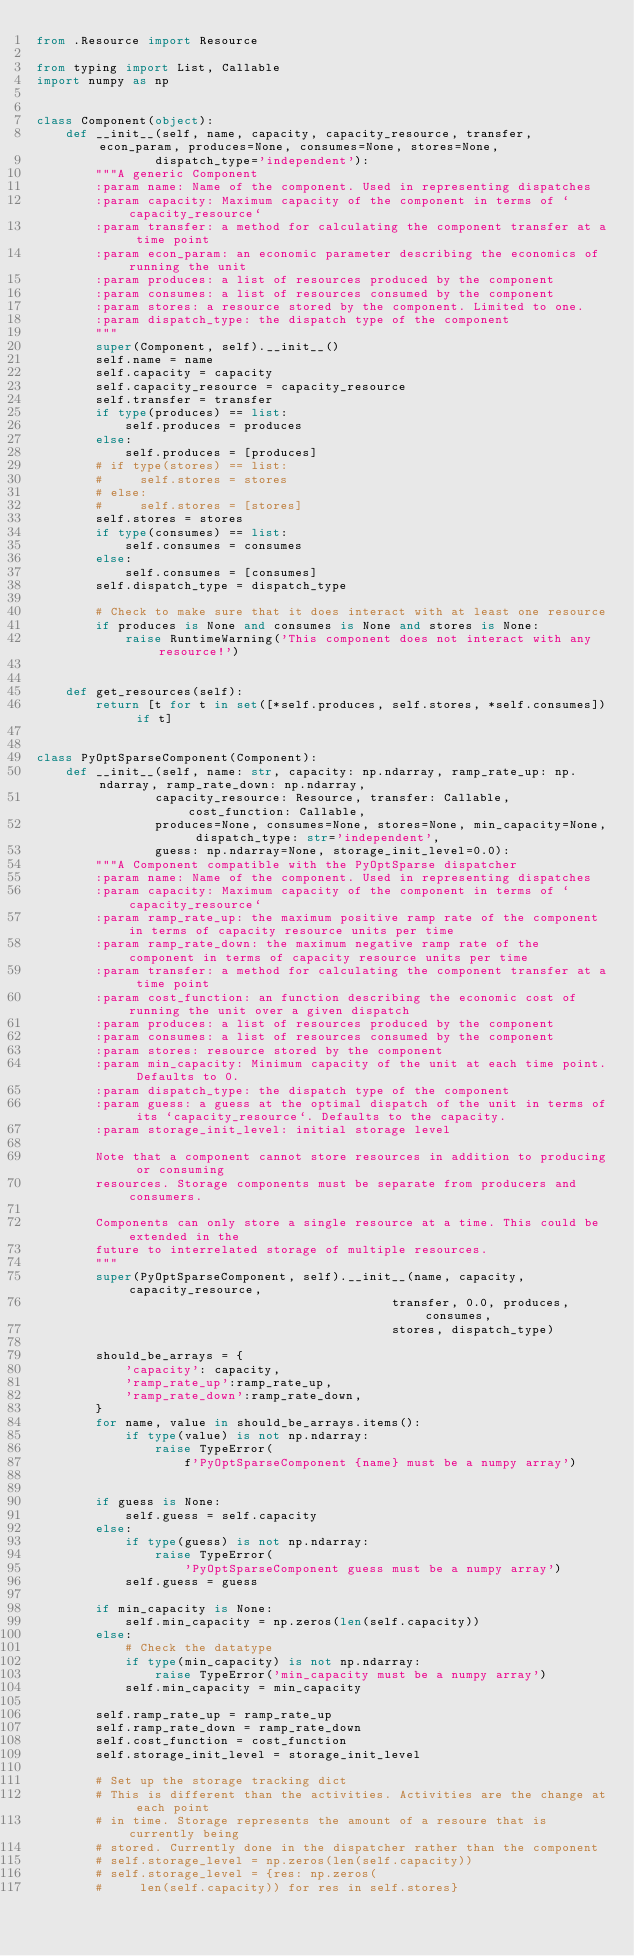Convert code to text. <code><loc_0><loc_0><loc_500><loc_500><_Python_>from .Resource import Resource

from typing import List, Callable
import numpy as np


class Component(object):
    def __init__(self, name, capacity, capacity_resource, transfer, econ_param, produces=None, consumes=None, stores=None,
                dispatch_type='independent'):
        """A generic Component
        :param name: Name of the component. Used in representing dispatches
        :param capacity: Maximum capacity of the component in terms of `capacity_resource`
        :param transfer: a method for calculating the component transfer at a time point
        :param econ_param: an economic parameter describing the economics of running the unit
        :param produces: a list of resources produced by the component
        :param consumes: a list of resources consumed by the component
        :param stores: a resource stored by the component. Limited to one.
        :param dispatch_type: the dispatch type of the component
        """
        super(Component, self).__init__()
        self.name = name
        self.capacity = capacity
        self.capacity_resource = capacity_resource
        self.transfer = transfer
        if type(produces) == list:
            self.produces = produces
        else:
            self.produces = [produces]
        # if type(stores) == list:
        #     self.stores = stores
        # else:
        #     self.stores = [stores]
        self.stores = stores
        if type(consumes) == list:
            self.consumes = consumes
        else:
            self.consumes = [consumes]
        self.dispatch_type = dispatch_type

        # Check to make sure that it does interact with at least one resource
        if produces is None and consumes is None and stores is None:
            raise RuntimeWarning('This component does not interact with any resource!')


    def get_resources(self):
        return [t for t in set([*self.produces, self.stores, *self.consumes]) if t]


class PyOptSparseComponent(Component):
    def __init__(self, name: str, capacity: np.ndarray, ramp_rate_up: np.ndarray, ramp_rate_down: np.ndarray,
                capacity_resource: Resource, transfer: Callable, cost_function: Callable,
                produces=None, consumes=None, stores=None, min_capacity=None, dispatch_type: str='independent',
                guess: np.ndarray=None, storage_init_level=0.0):
        """A Component compatible with the PyOptSparse dispatcher
        :param name: Name of the component. Used in representing dispatches
        :param capacity: Maximum capacity of the component in terms of `capacity_resource`
        :param ramp_rate_up: the maximum positive ramp rate of the component in terms of capacity resource units per time
        :param ramp_rate_down: the maximum negative ramp rate of the component in terms of capacity resource units per time
        :param transfer: a method for calculating the component transfer at a time point
        :param cost_function: an function describing the economic cost of running the unit over a given dispatch
        :param produces: a list of resources produced by the component
        :param consumes: a list of resources consumed by the component
        :param stores: resource stored by the component
        :param min_capacity: Minimum capacity of the unit at each time point. Defaults to 0.
        :param dispatch_type: the dispatch type of the component
        :param guess: a guess at the optimal dispatch of the unit in terms of its `capacity_resource`. Defaults to the capacity.
        :param storage_init_level: initial storage level

        Note that a component cannot store resources in addition to producing or consuming
        resources. Storage components must be separate from producers and consumers.

        Components can only store a single resource at a time. This could be extended in the
        future to interrelated storage of multiple resources.
        """
        super(PyOptSparseComponent, self).__init__(name, capacity, capacity_resource,
                                                transfer, 0.0, produces, consumes,
                                                stores, dispatch_type)

        should_be_arrays = {
            'capacity': capacity,
            'ramp_rate_up':ramp_rate_up,
            'ramp_rate_down':ramp_rate_down,
        }
        for name, value in should_be_arrays.items():
            if type(value) is not np.ndarray:
                raise TypeError(
                    f'PyOptSparseComponent {name} must be a numpy array')


        if guess is None:
            self.guess = self.capacity
        else:
            if type(guess) is not np.ndarray:
                raise TypeError(
                    'PyOptSparseComponent guess must be a numpy array')
            self.guess = guess

        if min_capacity is None:
            self.min_capacity = np.zeros(len(self.capacity))
        else:
            # Check the datatype
            if type(min_capacity) is not np.ndarray:
                raise TypeError('min_capacity must be a numpy array')
            self.min_capacity = min_capacity

        self.ramp_rate_up = ramp_rate_up
        self.ramp_rate_down = ramp_rate_down
        self.cost_function = cost_function
        self.storage_init_level = storage_init_level

        # Set up the storage tracking dict
        # This is different than the activities. Activities are the change at each point
        # in time. Storage represents the amount of a resoure that is currently being
        # stored. Currently done in the dispatcher rather than the component
        # self.storage_level = np.zeros(len(self.capacity))
        # self.storage_level = {res: np.zeros(
        #     len(self.capacity)) for res in self.stores}

</code> 